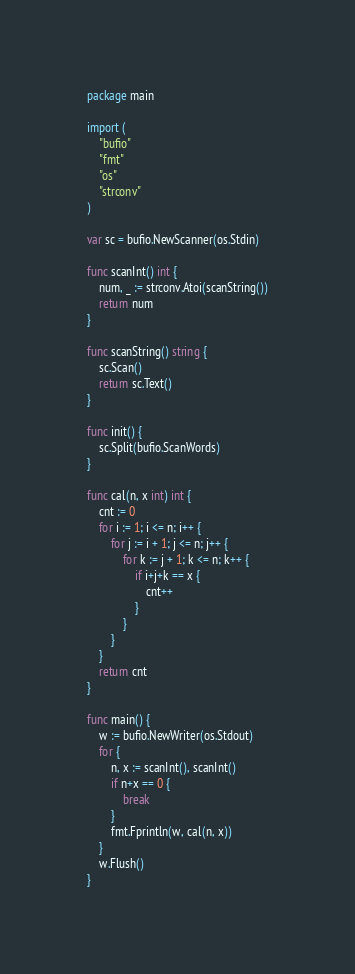Convert code to text. <code><loc_0><loc_0><loc_500><loc_500><_Go_>package main

import (
	"bufio"
	"fmt"
	"os"
	"strconv"
)

var sc = bufio.NewScanner(os.Stdin)

func scanInt() int {
	num, _ := strconv.Atoi(scanString())
	return num
}

func scanString() string {
	sc.Scan()
	return sc.Text()
}

func init() {
	sc.Split(bufio.ScanWords)
}

func cal(n, x int) int {
	cnt := 0
	for i := 1; i <= n; i++ {
		for j := i + 1; j <= n; j++ {
			for k := j + 1; k <= n; k++ {
				if i+j+k == x {
					cnt++
				}
			}
		}
	}
	return cnt
}

func main() {
	w := bufio.NewWriter(os.Stdout)
	for {
		n, x := scanInt(), scanInt()
		if n+x == 0 {
			break
		}
		fmt.Fprintln(w, cal(n, x))
	}
	w.Flush()
}

</code> 